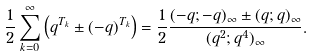Convert formula to latex. <formula><loc_0><loc_0><loc_500><loc_500>\frac { 1 } { 2 } \sum _ { k = 0 } ^ { \infty } \left ( q ^ { T _ { k } } \pm ( - q ) ^ { T _ { k } } \right ) = \frac { 1 } { 2 } \frac { ( - q ; - q ) _ { \infty } \pm ( q ; q ) _ { \infty } } { ( q ^ { 2 } ; q ^ { 4 } ) _ { \infty } } .</formula> 